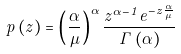Convert formula to latex. <formula><loc_0><loc_0><loc_500><loc_500>p \left ( z \right ) = \left ( \frac { \alpha } { \mu } \right ) ^ { \alpha } \frac { z ^ { \alpha - 1 } e ^ { - z \frac { \alpha } { \mu } } } { \Gamma \left ( \alpha \right ) }</formula> 